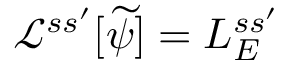<formula> <loc_0><loc_0><loc_500><loc_500>\mathcal { L } ^ { s s ^ { \prime } } [ \widetilde { \psi } ] = L _ { E } ^ { s s ^ { \prime } }</formula> 